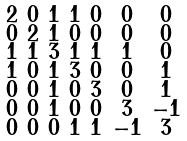<formula> <loc_0><loc_0><loc_500><loc_500>\begin{smallmatrix} 2 & 0 & 1 & 1 & 0 & 0 & 0 \\ 0 & 2 & 1 & 0 & 0 & 0 & 0 \\ 1 & 1 & 3 & 1 & 1 & 1 & 0 \\ 1 & 0 & 1 & 3 & 0 & 0 & 1 \\ 0 & 0 & 1 & 0 & 3 & 0 & 1 \\ 0 & 0 & 1 & 0 & 0 & 3 & - 1 \\ 0 & 0 & 0 & 1 & 1 & - 1 & 3 \end{smallmatrix}</formula> 